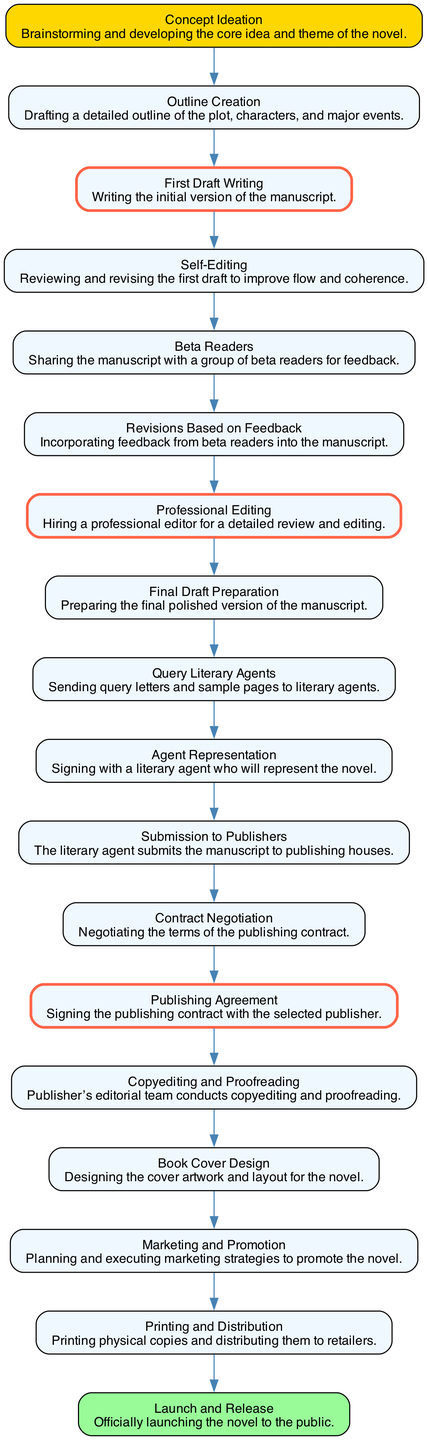What is the first step in the publishing process? The first step, as seen in the diagram, is "Concept Ideation," which involves brainstorming and developing the core idea of the novel.
Answer: Concept Ideation How many nodes are in the publishing process diagram? By counting each unique stage listed in the diagram, there are 17 distinct nodes representing various stages in the publishing process.
Answer: 17 Which stage comes immediately after "Self-Editing"? Following "Self-Editing," the next stage in the flow is "Beta Readers," showing the progression of the manuscript sharing process.
Answer: Beta Readers What are the key stages highlighted in the diagram? The key stages identified in the diagram include "First Draft Writing," "Professional Editing," and "Publishing Agreement," which are emphasized with thicker borders.
Answer: First Draft Writing, Professional Editing, Publishing Agreement How does "Query Literary Agents" relate to "Agent Representation"? "Query Literary Agents" precedes "Agent Representation," indicating that after querying agents, the author can sign with an agent who will represent the manuscript.
Answer: Proceeds to What step follows "Contract Negotiation"? The next step after "Contract Negotiation" is the "Publishing Agreement," indicating that the author signs the contract post-negotiation.
Answer: Publishing Agreement What is the last stage in the publishing process? The final stage in the flow is "Launch and Release," which indicates the official public release of the novel.
Answer: Launch and Release Identify the immediate preceding stage to "Copyediting and Proofreading." The stage that directly precedes "Copyediting and Proofreading" is "Publishing Agreement," showing the necessary administrative step before editing begins.
Answer: Publishing Agreement What happens after "Revisions Based on Feedback"? After making "Revisions Based on Feedback," the next step is "Professional Editing," which denotes the transition to hiring an editor.
Answer: Professional Editing 